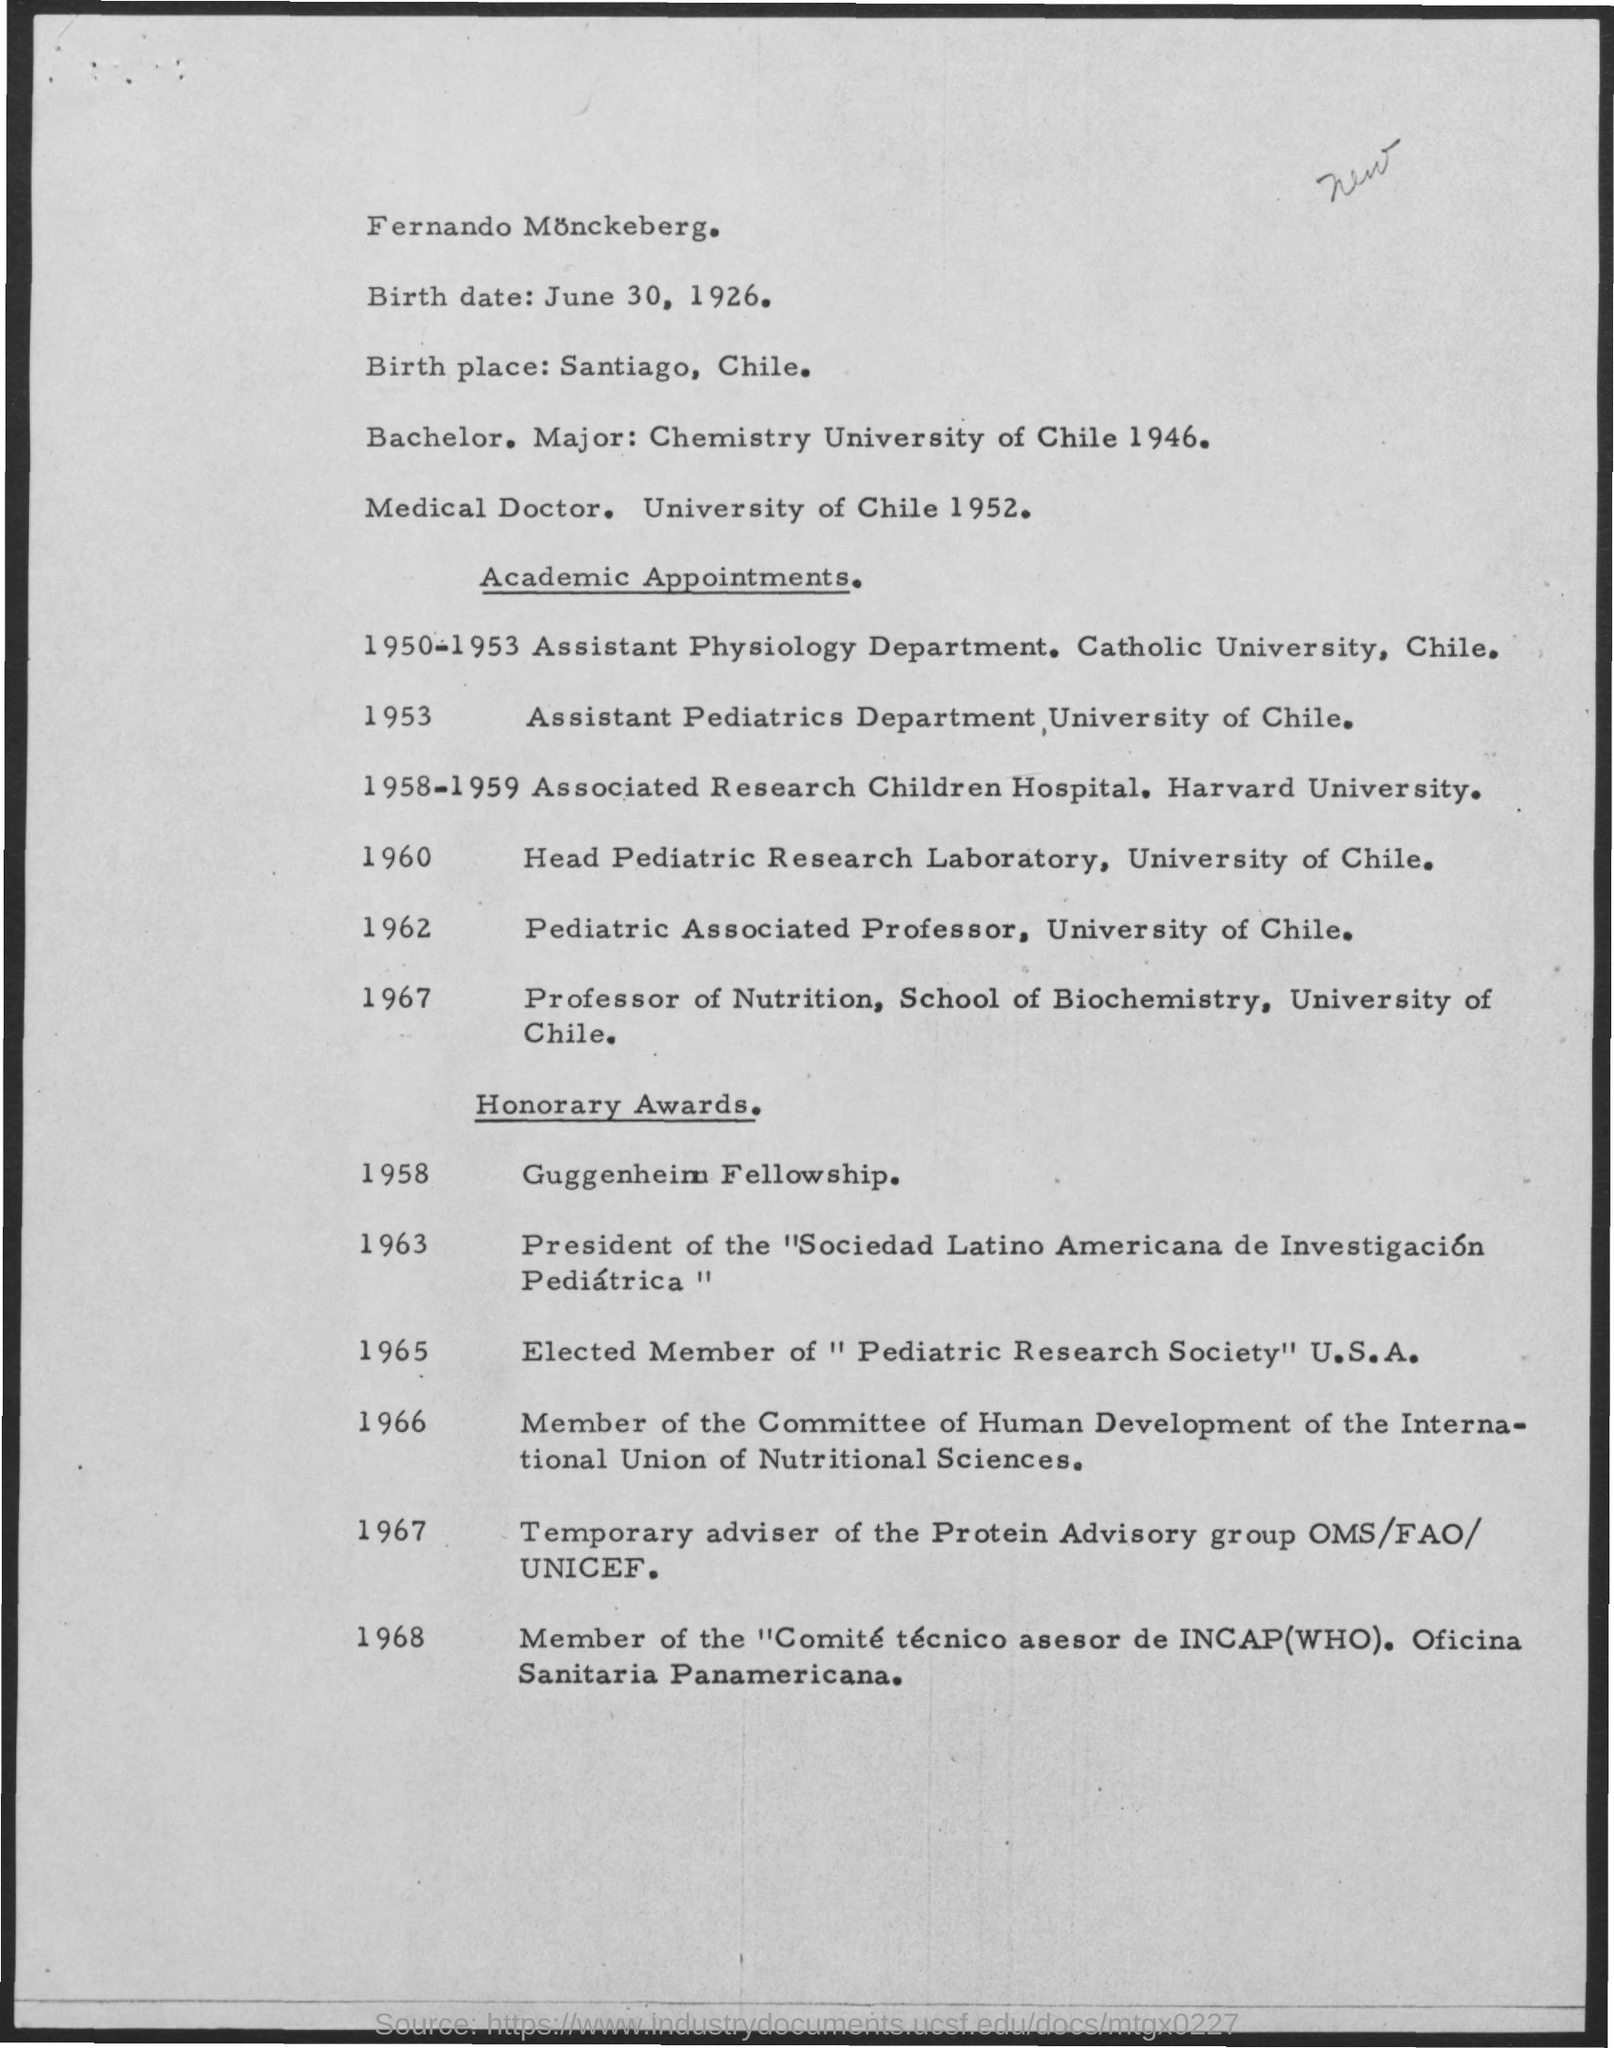Mention a couple of crucial points in this snapshot. The Guggenheim Fellowship was awarded in the year 1958. In 1953, Dr. Juan Rodriguez was appointed as the Assistant Pediatrics Department at the University of Chile. The birth date is June 30, 1926. In the year 1965, the individual was elected as a member of the Pediatric Research Society in the United States. 